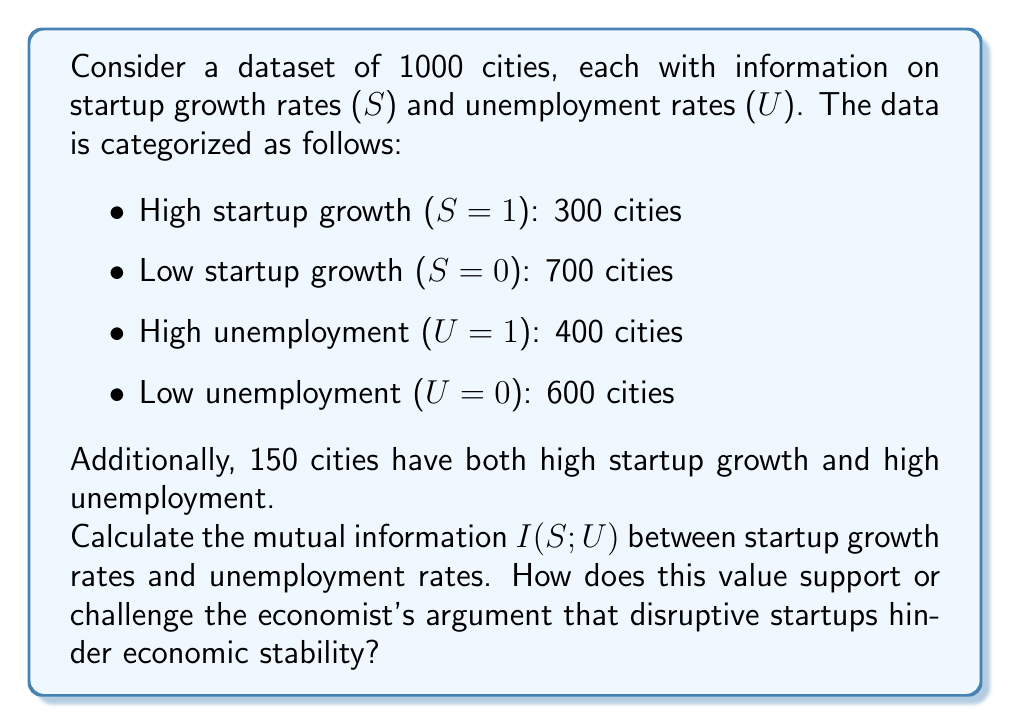Show me your answer to this math problem. To calculate the mutual information I(S;U), we need to follow these steps:

1) First, let's calculate the probabilities:

   P(S=1) = 300/1000 = 0.3
   P(S=0) = 700/1000 = 0.7
   P(U=1) = 400/1000 = 0.4
   P(U=0) = 600/1000 = 0.6
   P(S=1, U=1) = 150/1000 = 0.15

2) We can now calculate the remaining joint probabilities:

   P(S=1, U=0) = P(S=1) - P(S=1, U=1) = 0.3 - 0.15 = 0.15
   P(S=0, U=1) = P(U=1) - P(S=1, U=1) = 0.4 - 0.15 = 0.25
   P(S=0, U=0) = 1 - P(S=1, U=1) - P(S=1, U=0) - P(S=0, U=1) = 1 - 0.15 - 0.15 - 0.25 = 0.45

3) The mutual information is calculated using the formula:

   $$I(S;U) = \sum_{s \in S} \sum_{u \in U} P(s,u) \log_2 \frac{P(s,u)}{P(s)P(u)}$$

4) Let's calculate each term:

   $$0.15 \log_2 \frac{0.15}{0.3 \cdot 0.4} + 0.15 \log_2 \frac{0.15}{0.3 \cdot 0.6} + 0.25 \log_2 \frac{0.25}{0.7 \cdot 0.4} + 0.45 \log_2 \frac{0.45}{0.7 \cdot 0.6}$$

5) Calculating each term:

   $$0.15 \log_2 1.25 + 0.15 \log_2 0.833 + 0.25 \log_2 0.893 + 0.45 \log_2 1.071$$

6) Evaluating:

   $$0.15 \cdot 0.322 + 0.15 \cdot (-0.263) + 0.25 \cdot (-0.163) + 0.45 \cdot 0.099$$

7) Summing up:

   $$0.0483 - 0.0395 - 0.0408 + 0.0446 = 0.0126$$

The mutual information I(S;U) is approximately 0.0126 bits.

This low value suggests a weak relationship between startup growth rates and unemployment rates. It challenges the economist's argument that disruptive startups hinder economic stability, as there isn't a strong information-theoretic dependency between these variables. However, the economist might argue that this weak relationship is due to other compensating factors in the economy, or that the impact of startups on job security is more nuanced than can be captured by unemployment rates alone.
Answer: The mutual information I(S;U) between startup growth rates and unemployment rates is approximately 0.0126 bits. 